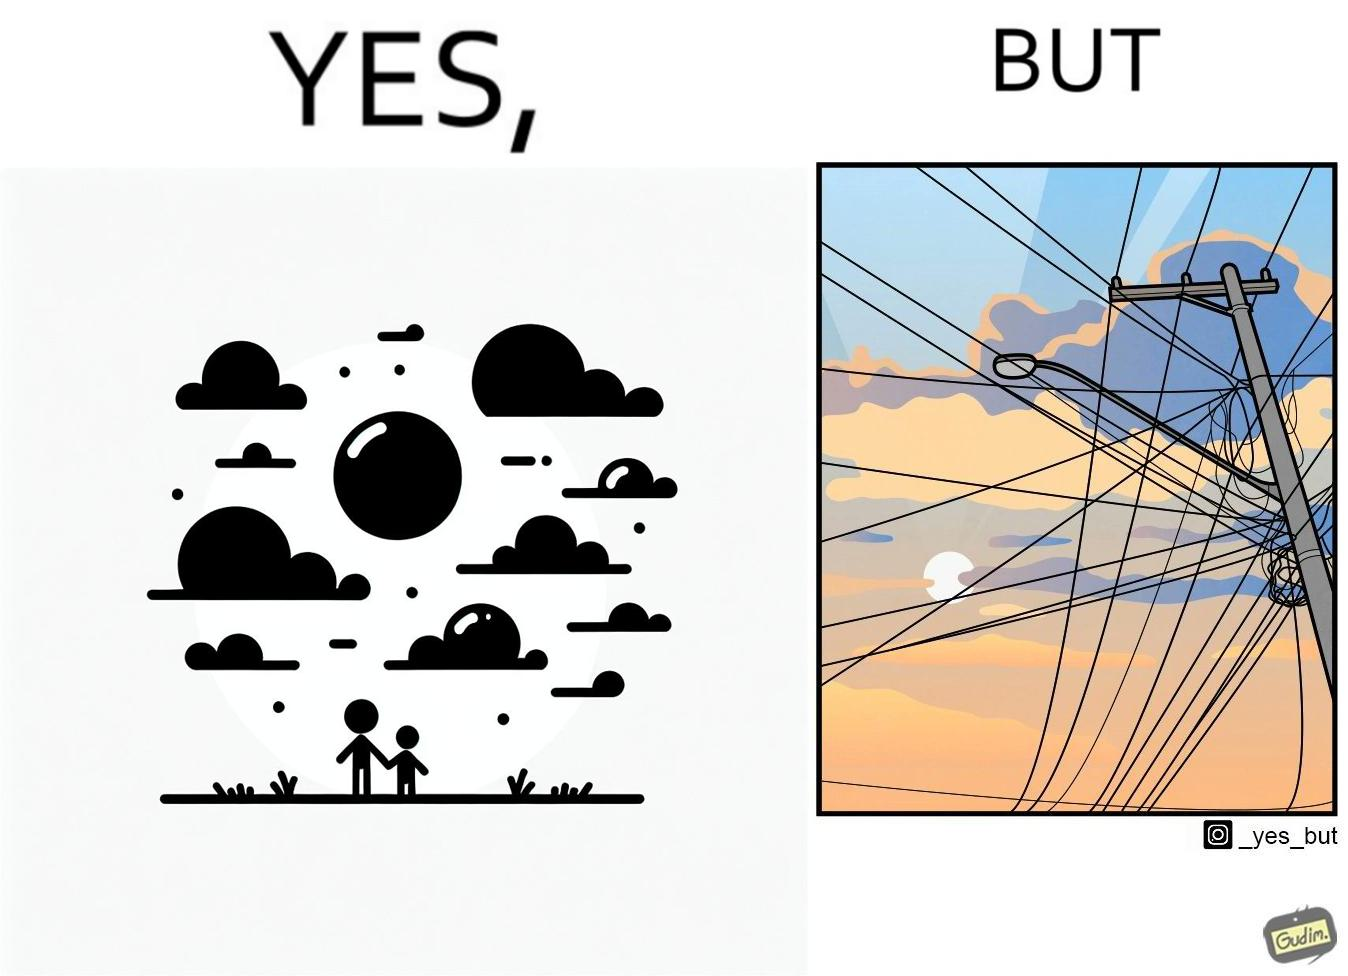Compare the left and right sides of this image. In the left part of the image: a clear sky with sun and clouds In the right part of the image: an electricity pole with a lot of wires over it 